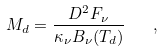Convert formula to latex. <formula><loc_0><loc_0><loc_500><loc_500>M _ { d } = \frac { D ^ { 2 } F _ { \nu } } { \kappa _ { \nu } B _ { \nu } ( T _ { d } ) } \quad ,</formula> 